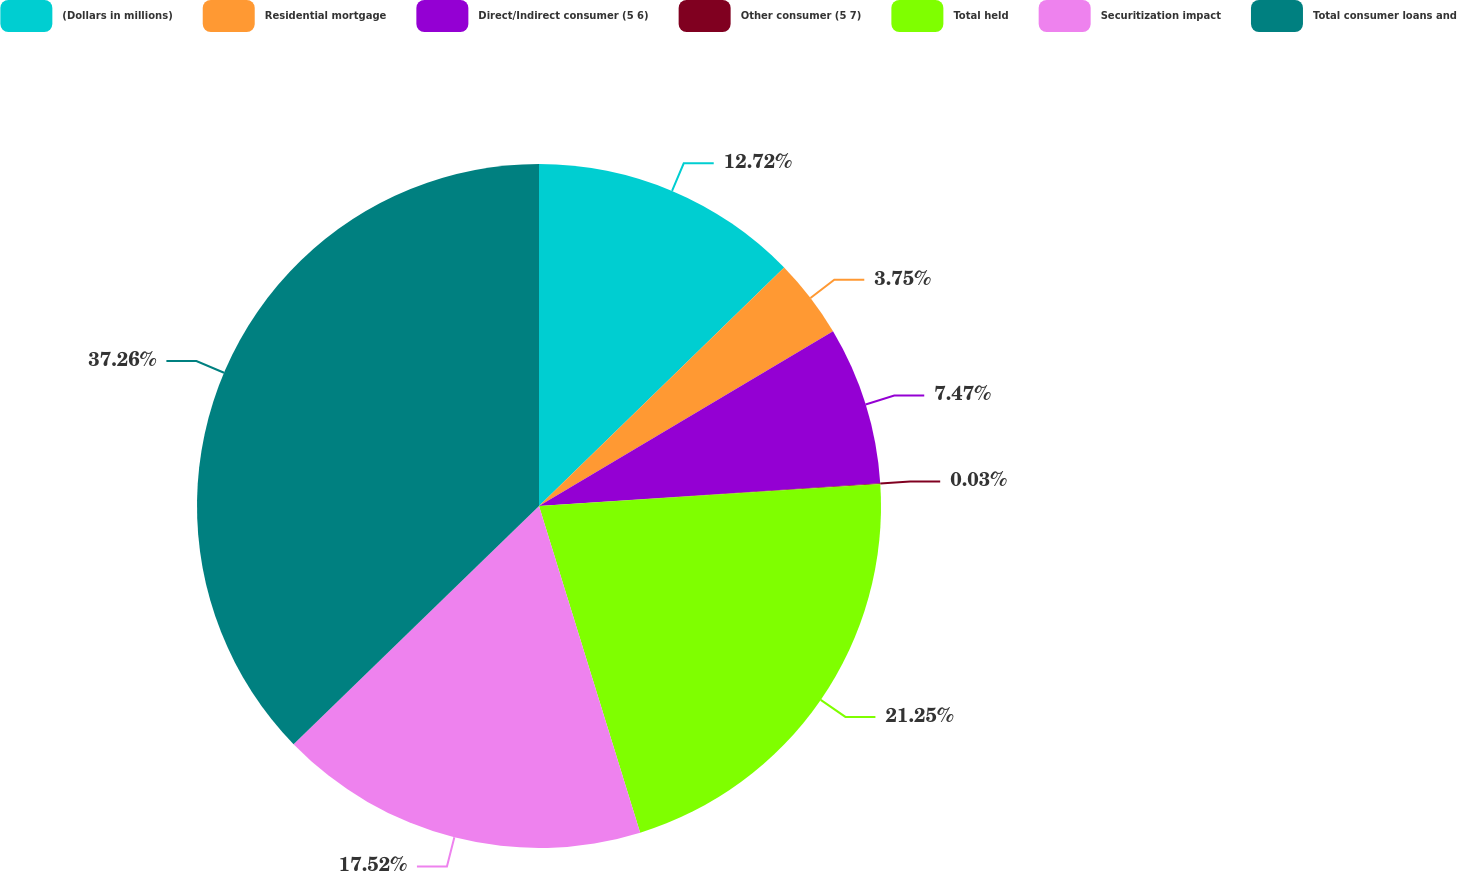Convert chart to OTSL. <chart><loc_0><loc_0><loc_500><loc_500><pie_chart><fcel>(Dollars in millions)<fcel>Residential mortgage<fcel>Direct/Indirect consumer (5 6)<fcel>Other consumer (5 7)<fcel>Total held<fcel>Securitization impact<fcel>Total consumer loans and<nl><fcel>12.72%<fcel>3.75%<fcel>7.47%<fcel>0.03%<fcel>21.25%<fcel>17.52%<fcel>37.26%<nl></chart> 